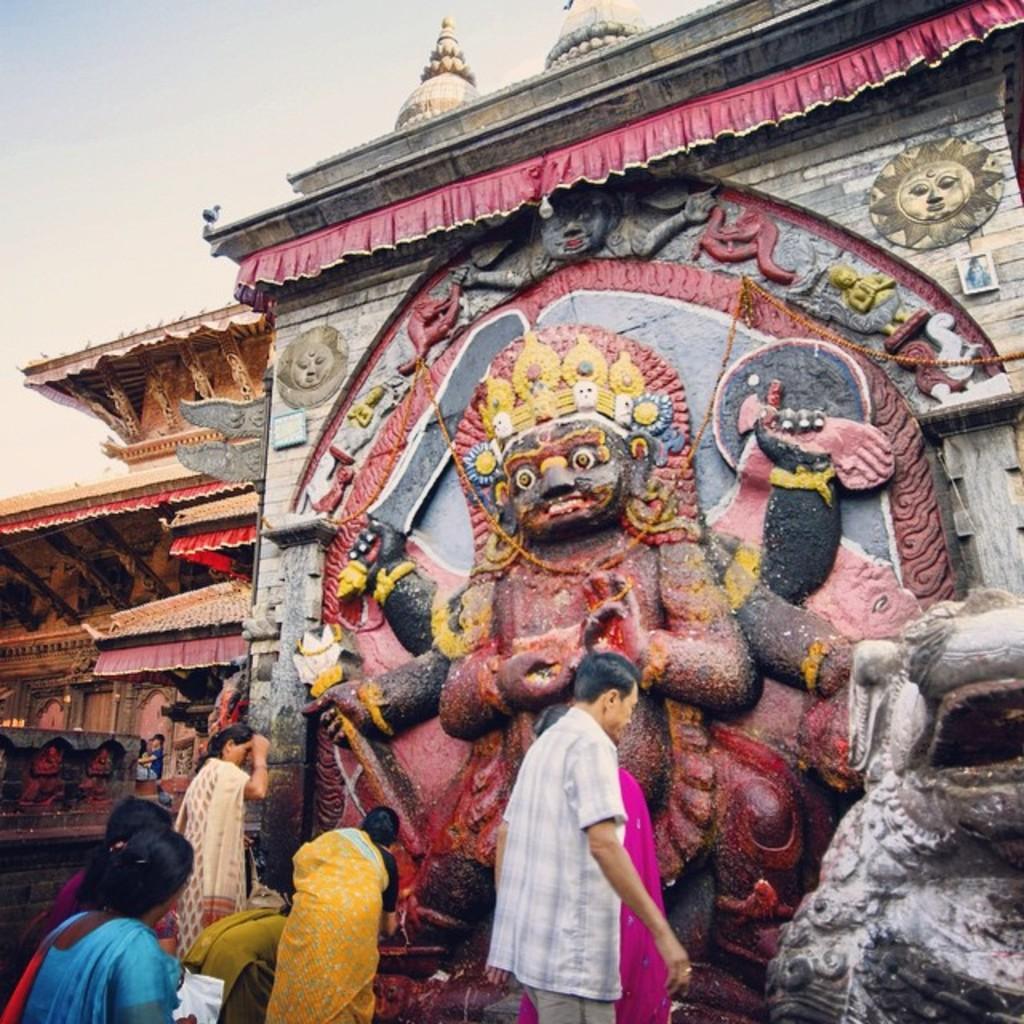Can you describe this image briefly? This picture is clicked outside. In the foreground we can see the group of persons. On the right corner we can see the sculpture of some object. In the center we can see the stone wall and we can see the stone carving of the sun and the stone carvings of some other objects on the wall and we can see the sculpture of a person and in the background we can see the sky and some other objects. 